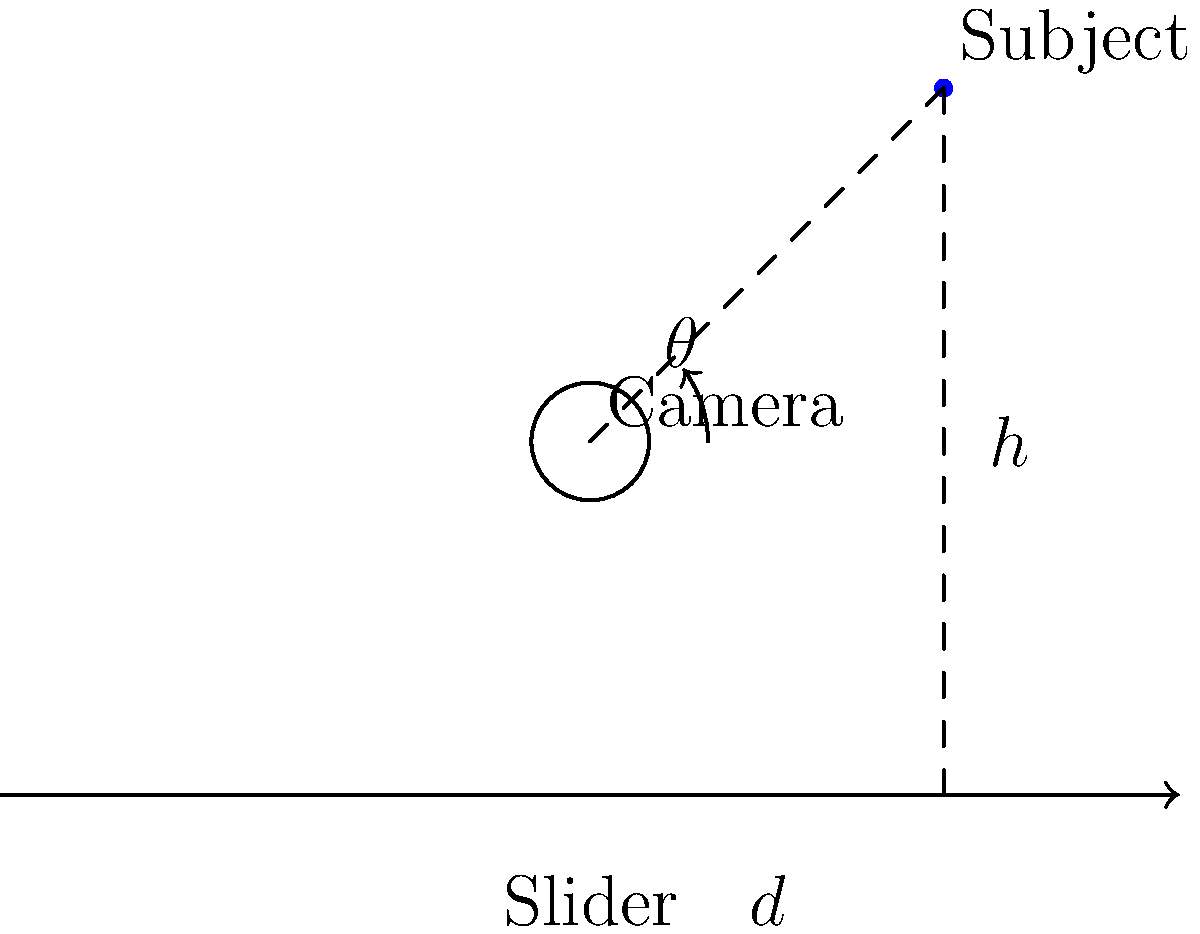As a videographer working with Casey Neistat, you're setting up a slider shot. The subject is positioned 30 cm above and 30 cm horizontally from the end of a 100 cm slider. If you want to maintain the subject in the center of the frame throughout the shot, what should be the tilt angle ($\theta$) of the camera when it's positioned in the middle of the slider? To solve this problem, we need to follow these steps:

1. Identify the known variables:
   - Slider length = 100 cm
   - Camera position = middle of slider = 50 cm from either end
   - Subject position = 30 cm above and 30 cm horizontally from slider end

2. Calculate the horizontal distance ($d$) from the camera to the subject:
   $d = 30 \text{ cm} + (100 \text{ cm} - 50 \text{ cm}) = 80 \text{ cm}$

3. The vertical distance ($h$) from the camera to the subject is given:
   $h = 30 \text{ cm}$

4. Use the arctangent function to calculate the tilt angle:
   $\theta = \arctan(\frac{h}{d})$

5. Substitute the values:
   $\theta = \arctan(\frac{30 \text{ cm}}{80 \text{ cm}})$

6. Calculate the result:
   $\theta \approx 20.56°$

Therefore, the camera should be tilted at an angle of approximately 20.56° to keep the subject centered in the frame when the camera is in the middle of the slider.
Answer: $20.56°$ 